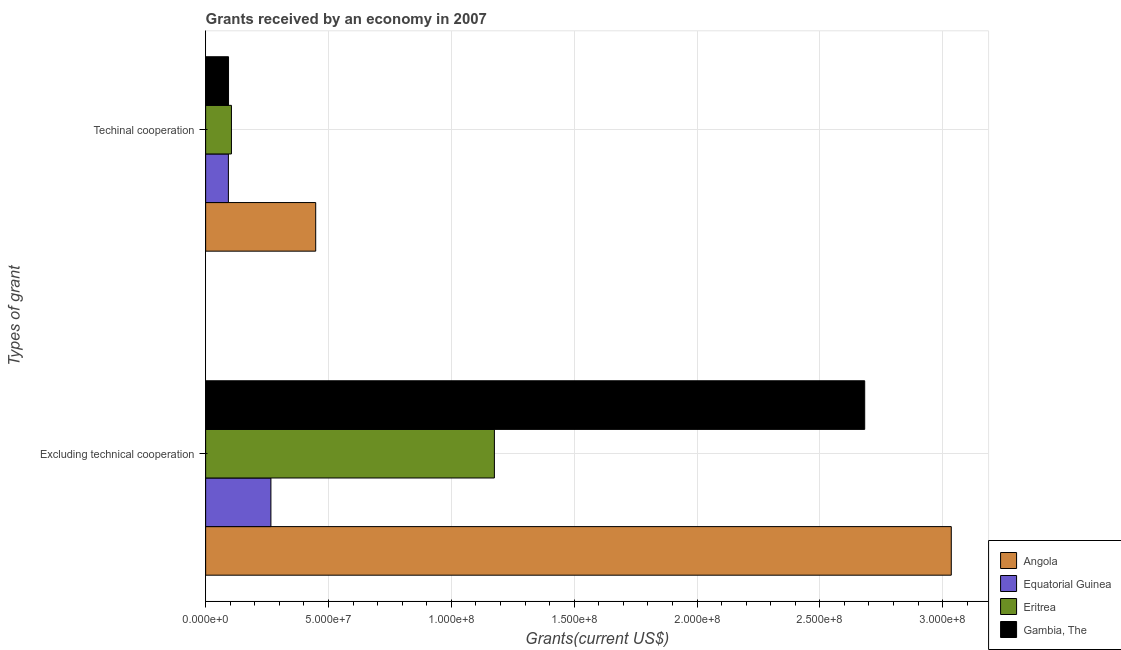Are the number of bars per tick equal to the number of legend labels?
Offer a very short reply. Yes. How many bars are there on the 1st tick from the bottom?
Make the answer very short. 4. What is the label of the 2nd group of bars from the top?
Your answer should be compact. Excluding technical cooperation. What is the amount of grants received(excluding technical cooperation) in Angola?
Your response must be concise. 3.04e+08. Across all countries, what is the maximum amount of grants received(including technical cooperation)?
Make the answer very short. 4.48e+07. Across all countries, what is the minimum amount of grants received(including technical cooperation)?
Make the answer very short. 9.26e+06. In which country was the amount of grants received(excluding technical cooperation) maximum?
Offer a very short reply. Angola. In which country was the amount of grants received(excluding technical cooperation) minimum?
Ensure brevity in your answer.  Equatorial Guinea. What is the total amount of grants received(including technical cooperation) in the graph?
Provide a short and direct response. 7.39e+07. What is the difference between the amount of grants received(excluding technical cooperation) in Angola and that in Gambia, The?
Provide a succinct answer. 3.52e+07. What is the difference between the amount of grants received(including technical cooperation) in Eritrea and the amount of grants received(excluding technical cooperation) in Angola?
Ensure brevity in your answer.  -2.93e+08. What is the average amount of grants received(excluding technical cooperation) per country?
Keep it short and to the point. 1.79e+08. What is the difference between the amount of grants received(excluding technical cooperation) and amount of grants received(including technical cooperation) in Gambia, The?
Offer a very short reply. 2.59e+08. In how many countries, is the amount of grants received(excluding technical cooperation) greater than 280000000 US$?
Give a very brief answer. 1. What is the ratio of the amount of grants received(excluding technical cooperation) in Gambia, The to that in Equatorial Guinea?
Make the answer very short. 10.1. What does the 1st bar from the top in Excluding technical cooperation represents?
Make the answer very short. Gambia, The. What does the 3rd bar from the bottom in Excluding technical cooperation represents?
Your answer should be very brief. Eritrea. Are all the bars in the graph horizontal?
Offer a terse response. Yes. How many countries are there in the graph?
Make the answer very short. 4. Are the values on the major ticks of X-axis written in scientific E-notation?
Offer a very short reply. Yes. Does the graph contain any zero values?
Ensure brevity in your answer.  No. Where does the legend appear in the graph?
Ensure brevity in your answer.  Bottom right. How many legend labels are there?
Keep it short and to the point. 4. What is the title of the graph?
Keep it short and to the point. Grants received by an economy in 2007. What is the label or title of the X-axis?
Offer a very short reply. Grants(current US$). What is the label or title of the Y-axis?
Your answer should be compact. Types of grant. What is the Grants(current US$) of Angola in Excluding technical cooperation?
Provide a succinct answer. 3.04e+08. What is the Grants(current US$) of Equatorial Guinea in Excluding technical cooperation?
Keep it short and to the point. 2.66e+07. What is the Grants(current US$) of Eritrea in Excluding technical cooperation?
Your response must be concise. 1.18e+08. What is the Grants(current US$) of Gambia, The in Excluding technical cooperation?
Provide a short and direct response. 2.68e+08. What is the Grants(current US$) in Angola in Techinal cooperation?
Provide a succinct answer. 4.48e+07. What is the Grants(current US$) in Equatorial Guinea in Techinal cooperation?
Offer a very short reply. 9.26e+06. What is the Grants(current US$) in Eritrea in Techinal cooperation?
Offer a terse response. 1.05e+07. What is the Grants(current US$) of Gambia, The in Techinal cooperation?
Offer a very short reply. 9.32e+06. Across all Types of grant, what is the maximum Grants(current US$) of Angola?
Your answer should be very brief. 3.04e+08. Across all Types of grant, what is the maximum Grants(current US$) of Equatorial Guinea?
Your answer should be compact. 2.66e+07. Across all Types of grant, what is the maximum Grants(current US$) in Eritrea?
Give a very brief answer. 1.18e+08. Across all Types of grant, what is the maximum Grants(current US$) of Gambia, The?
Make the answer very short. 2.68e+08. Across all Types of grant, what is the minimum Grants(current US$) in Angola?
Ensure brevity in your answer.  4.48e+07. Across all Types of grant, what is the minimum Grants(current US$) of Equatorial Guinea?
Give a very brief answer. 9.26e+06. Across all Types of grant, what is the minimum Grants(current US$) in Eritrea?
Your answer should be very brief. 1.05e+07. Across all Types of grant, what is the minimum Grants(current US$) in Gambia, The?
Ensure brevity in your answer.  9.32e+06. What is the total Grants(current US$) of Angola in the graph?
Your response must be concise. 3.48e+08. What is the total Grants(current US$) in Equatorial Guinea in the graph?
Your response must be concise. 3.58e+07. What is the total Grants(current US$) in Eritrea in the graph?
Offer a terse response. 1.28e+08. What is the total Grants(current US$) of Gambia, The in the graph?
Offer a very short reply. 2.78e+08. What is the difference between the Grants(current US$) in Angola in Excluding technical cooperation and that in Techinal cooperation?
Give a very brief answer. 2.59e+08. What is the difference between the Grants(current US$) in Equatorial Guinea in Excluding technical cooperation and that in Techinal cooperation?
Offer a very short reply. 1.73e+07. What is the difference between the Grants(current US$) of Eritrea in Excluding technical cooperation and that in Techinal cooperation?
Your answer should be very brief. 1.07e+08. What is the difference between the Grants(current US$) in Gambia, The in Excluding technical cooperation and that in Techinal cooperation?
Give a very brief answer. 2.59e+08. What is the difference between the Grants(current US$) of Angola in Excluding technical cooperation and the Grants(current US$) of Equatorial Guinea in Techinal cooperation?
Your answer should be compact. 2.94e+08. What is the difference between the Grants(current US$) of Angola in Excluding technical cooperation and the Grants(current US$) of Eritrea in Techinal cooperation?
Offer a terse response. 2.93e+08. What is the difference between the Grants(current US$) in Angola in Excluding technical cooperation and the Grants(current US$) in Gambia, The in Techinal cooperation?
Offer a terse response. 2.94e+08. What is the difference between the Grants(current US$) of Equatorial Guinea in Excluding technical cooperation and the Grants(current US$) of Eritrea in Techinal cooperation?
Your answer should be very brief. 1.61e+07. What is the difference between the Grants(current US$) of Equatorial Guinea in Excluding technical cooperation and the Grants(current US$) of Gambia, The in Techinal cooperation?
Provide a short and direct response. 1.72e+07. What is the difference between the Grants(current US$) in Eritrea in Excluding technical cooperation and the Grants(current US$) in Gambia, The in Techinal cooperation?
Give a very brief answer. 1.08e+08. What is the average Grants(current US$) in Angola per Types of grant?
Your answer should be very brief. 1.74e+08. What is the average Grants(current US$) of Equatorial Guinea per Types of grant?
Provide a succinct answer. 1.79e+07. What is the average Grants(current US$) in Eritrea per Types of grant?
Offer a terse response. 6.40e+07. What is the average Grants(current US$) of Gambia, The per Types of grant?
Offer a very short reply. 1.39e+08. What is the difference between the Grants(current US$) of Angola and Grants(current US$) of Equatorial Guinea in Excluding technical cooperation?
Make the answer very short. 2.77e+08. What is the difference between the Grants(current US$) of Angola and Grants(current US$) of Eritrea in Excluding technical cooperation?
Provide a succinct answer. 1.86e+08. What is the difference between the Grants(current US$) in Angola and Grants(current US$) in Gambia, The in Excluding technical cooperation?
Provide a succinct answer. 3.52e+07. What is the difference between the Grants(current US$) in Equatorial Guinea and Grants(current US$) in Eritrea in Excluding technical cooperation?
Offer a terse response. -9.10e+07. What is the difference between the Grants(current US$) in Equatorial Guinea and Grants(current US$) in Gambia, The in Excluding technical cooperation?
Keep it short and to the point. -2.42e+08. What is the difference between the Grants(current US$) of Eritrea and Grants(current US$) of Gambia, The in Excluding technical cooperation?
Keep it short and to the point. -1.51e+08. What is the difference between the Grants(current US$) in Angola and Grants(current US$) in Equatorial Guinea in Techinal cooperation?
Give a very brief answer. 3.55e+07. What is the difference between the Grants(current US$) of Angola and Grants(current US$) of Eritrea in Techinal cooperation?
Make the answer very short. 3.43e+07. What is the difference between the Grants(current US$) in Angola and Grants(current US$) in Gambia, The in Techinal cooperation?
Your response must be concise. 3.55e+07. What is the difference between the Grants(current US$) in Equatorial Guinea and Grants(current US$) in Eritrea in Techinal cooperation?
Ensure brevity in your answer.  -1.24e+06. What is the difference between the Grants(current US$) in Eritrea and Grants(current US$) in Gambia, The in Techinal cooperation?
Keep it short and to the point. 1.18e+06. What is the ratio of the Grants(current US$) in Angola in Excluding technical cooperation to that in Techinal cooperation?
Offer a terse response. 6.77. What is the ratio of the Grants(current US$) in Equatorial Guinea in Excluding technical cooperation to that in Techinal cooperation?
Your response must be concise. 2.87. What is the ratio of the Grants(current US$) in Eritrea in Excluding technical cooperation to that in Techinal cooperation?
Your answer should be very brief. 11.19. What is the ratio of the Grants(current US$) of Gambia, The in Excluding technical cooperation to that in Techinal cooperation?
Offer a terse response. 28.78. What is the difference between the highest and the second highest Grants(current US$) of Angola?
Offer a very short reply. 2.59e+08. What is the difference between the highest and the second highest Grants(current US$) of Equatorial Guinea?
Give a very brief answer. 1.73e+07. What is the difference between the highest and the second highest Grants(current US$) in Eritrea?
Give a very brief answer. 1.07e+08. What is the difference between the highest and the second highest Grants(current US$) of Gambia, The?
Your response must be concise. 2.59e+08. What is the difference between the highest and the lowest Grants(current US$) of Angola?
Offer a terse response. 2.59e+08. What is the difference between the highest and the lowest Grants(current US$) in Equatorial Guinea?
Your response must be concise. 1.73e+07. What is the difference between the highest and the lowest Grants(current US$) of Eritrea?
Provide a short and direct response. 1.07e+08. What is the difference between the highest and the lowest Grants(current US$) in Gambia, The?
Your response must be concise. 2.59e+08. 